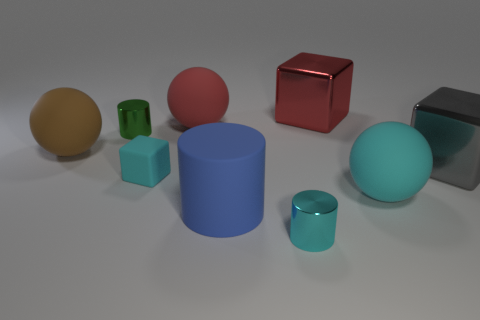Are there fewer tiny cyan cylinders that are on the left side of the large red matte ball than brown matte blocks?
Provide a short and direct response. No. What shape is the brown thing that is the same material as the big cylinder?
Provide a short and direct response. Sphere. How many cylinders are the same color as the small matte block?
Ensure brevity in your answer.  1. What number of objects are green metallic spheres or cylinders?
Provide a succinct answer. 3. There is a ball that is on the left side of the cylinder behind the big cyan thing; what is its material?
Ensure brevity in your answer.  Rubber. Are there any large cyan balls made of the same material as the tiny green object?
Offer a terse response. No. What is the shape of the metallic object on the right side of the matte sphere to the right of the large red thing to the right of the rubber cylinder?
Your answer should be very brief. Cube. What is the blue cylinder made of?
Your answer should be very brief. Rubber. What is the color of the tiny thing that is made of the same material as the large blue cylinder?
Make the answer very short. Cyan. There is a cube that is in front of the gray cube; are there any metal objects to the right of it?
Give a very brief answer. Yes. 